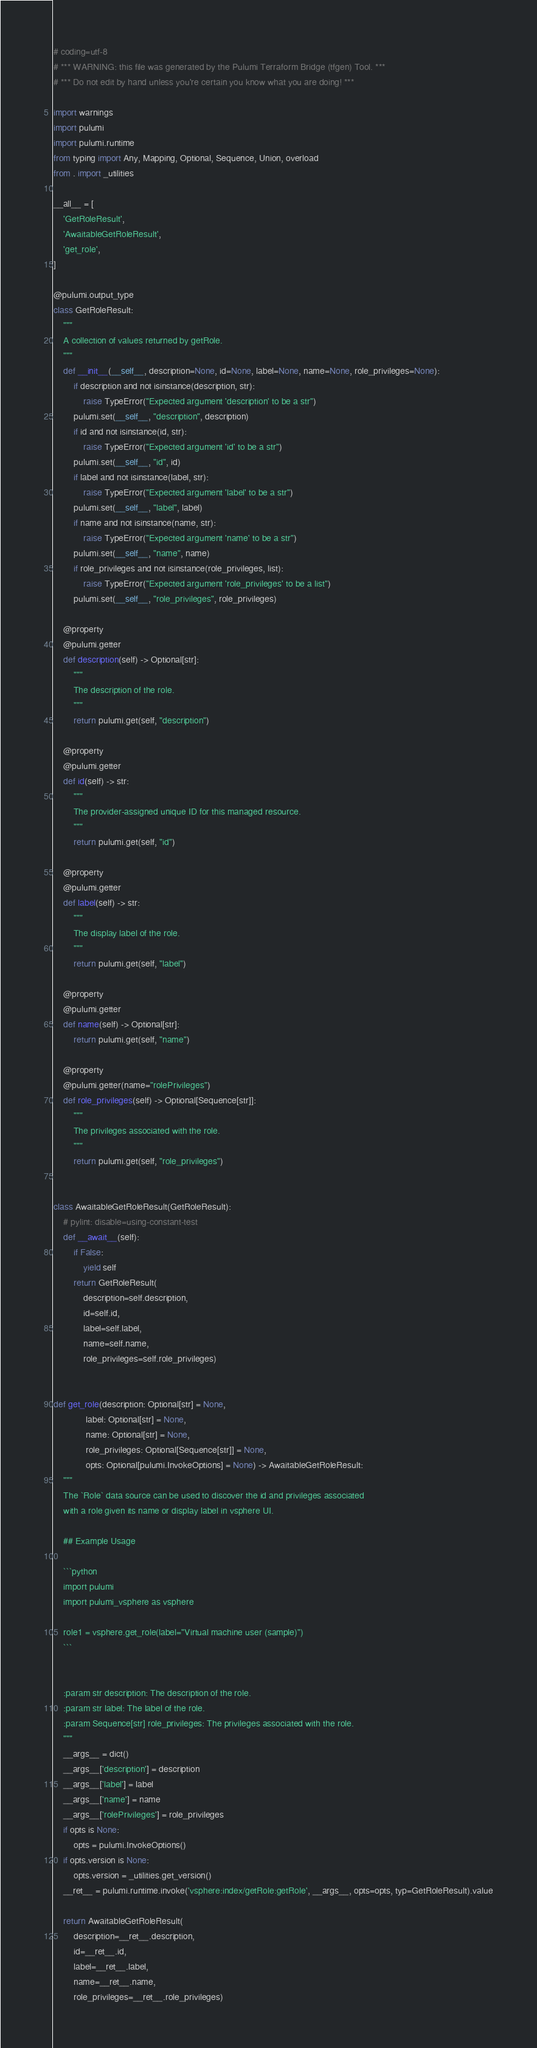<code> <loc_0><loc_0><loc_500><loc_500><_Python_># coding=utf-8
# *** WARNING: this file was generated by the Pulumi Terraform Bridge (tfgen) Tool. ***
# *** Do not edit by hand unless you're certain you know what you are doing! ***

import warnings
import pulumi
import pulumi.runtime
from typing import Any, Mapping, Optional, Sequence, Union, overload
from . import _utilities

__all__ = [
    'GetRoleResult',
    'AwaitableGetRoleResult',
    'get_role',
]

@pulumi.output_type
class GetRoleResult:
    """
    A collection of values returned by getRole.
    """
    def __init__(__self__, description=None, id=None, label=None, name=None, role_privileges=None):
        if description and not isinstance(description, str):
            raise TypeError("Expected argument 'description' to be a str")
        pulumi.set(__self__, "description", description)
        if id and not isinstance(id, str):
            raise TypeError("Expected argument 'id' to be a str")
        pulumi.set(__self__, "id", id)
        if label and not isinstance(label, str):
            raise TypeError("Expected argument 'label' to be a str")
        pulumi.set(__self__, "label", label)
        if name and not isinstance(name, str):
            raise TypeError("Expected argument 'name' to be a str")
        pulumi.set(__self__, "name", name)
        if role_privileges and not isinstance(role_privileges, list):
            raise TypeError("Expected argument 'role_privileges' to be a list")
        pulumi.set(__self__, "role_privileges", role_privileges)

    @property
    @pulumi.getter
    def description(self) -> Optional[str]:
        """
        The description of the role.
        """
        return pulumi.get(self, "description")

    @property
    @pulumi.getter
    def id(self) -> str:
        """
        The provider-assigned unique ID for this managed resource.
        """
        return pulumi.get(self, "id")

    @property
    @pulumi.getter
    def label(self) -> str:
        """
        The display label of the role.
        """
        return pulumi.get(self, "label")

    @property
    @pulumi.getter
    def name(self) -> Optional[str]:
        return pulumi.get(self, "name")

    @property
    @pulumi.getter(name="rolePrivileges")
    def role_privileges(self) -> Optional[Sequence[str]]:
        """
        The privileges associated with the role.
        """
        return pulumi.get(self, "role_privileges")


class AwaitableGetRoleResult(GetRoleResult):
    # pylint: disable=using-constant-test
    def __await__(self):
        if False:
            yield self
        return GetRoleResult(
            description=self.description,
            id=self.id,
            label=self.label,
            name=self.name,
            role_privileges=self.role_privileges)


def get_role(description: Optional[str] = None,
             label: Optional[str] = None,
             name: Optional[str] = None,
             role_privileges: Optional[Sequence[str]] = None,
             opts: Optional[pulumi.InvokeOptions] = None) -> AwaitableGetRoleResult:
    """
    The `Role` data source can be used to discover the id and privileges associated
    with a role given its name or display label in vsphere UI.

    ## Example Usage

    ```python
    import pulumi
    import pulumi_vsphere as vsphere

    role1 = vsphere.get_role(label="Virtual machine user (sample)")
    ```


    :param str description: The description of the role.
    :param str label: The label of the role.
    :param Sequence[str] role_privileges: The privileges associated with the role.
    """
    __args__ = dict()
    __args__['description'] = description
    __args__['label'] = label
    __args__['name'] = name
    __args__['rolePrivileges'] = role_privileges
    if opts is None:
        opts = pulumi.InvokeOptions()
    if opts.version is None:
        opts.version = _utilities.get_version()
    __ret__ = pulumi.runtime.invoke('vsphere:index/getRole:getRole', __args__, opts=opts, typ=GetRoleResult).value

    return AwaitableGetRoleResult(
        description=__ret__.description,
        id=__ret__.id,
        label=__ret__.label,
        name=__ret__.name,
        role_privileges=__ret__.role_privileges)
</code> 